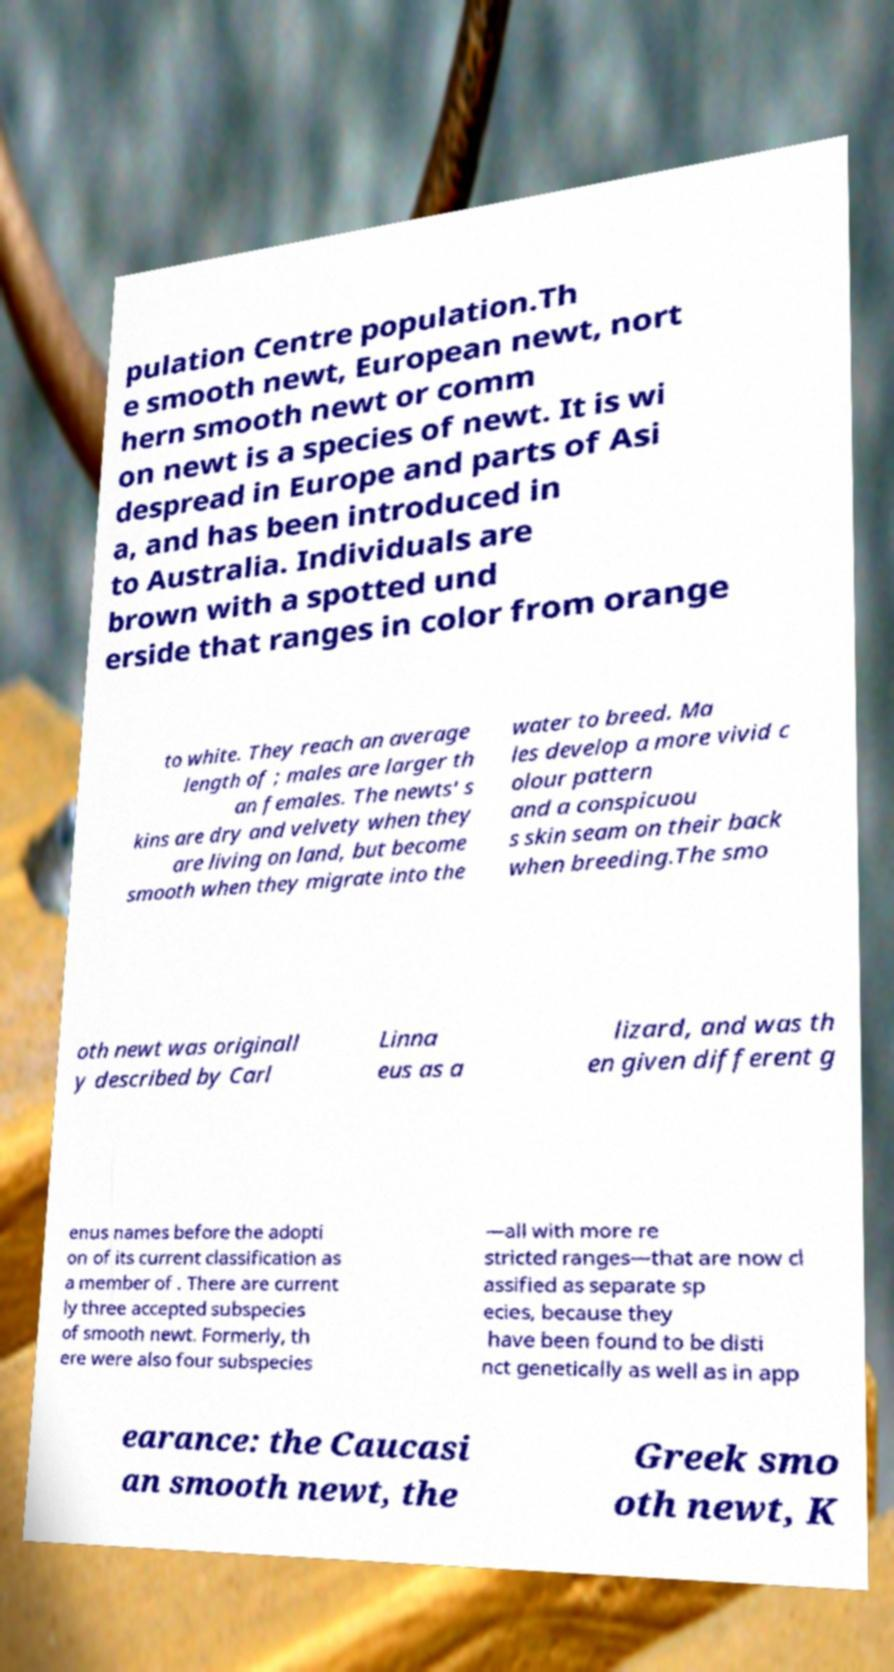Please read and relay the text visible in this image. What does it say? pulation Centre population.Th e smooth newt, European newt, nort hern smooth newt or comm on newt is a species of newt. It is wi despread in Europe and parts of Asi a, and has been introduced in to Australia. Individuals are brown with a spotted und erside that ranges in color from orange to white. They reach an average length of ; males are larger th an females. The newts' s kins are dry and velvety when they are living on land, but become smooth when they migrate into the water to breed. Ma les develop a more vivid c olour pattern and a conspicuou s skin seam on their back when breeding.The smo oth newt was originall y described by Carl Linna eus as a lizard, and was th en given different g enus names before the adopti on of its current classification as a member of . There are current ly three accepted subspecies of smooth newt. Formerly, th ere were also four subspecies —all with more re stricted ranges—that are now cl assified as separate sp ecies, because they have been found to be disti nct genetically as well as in app earance: the Caucasi an smooth newt, the Greek smo oth newt, K 